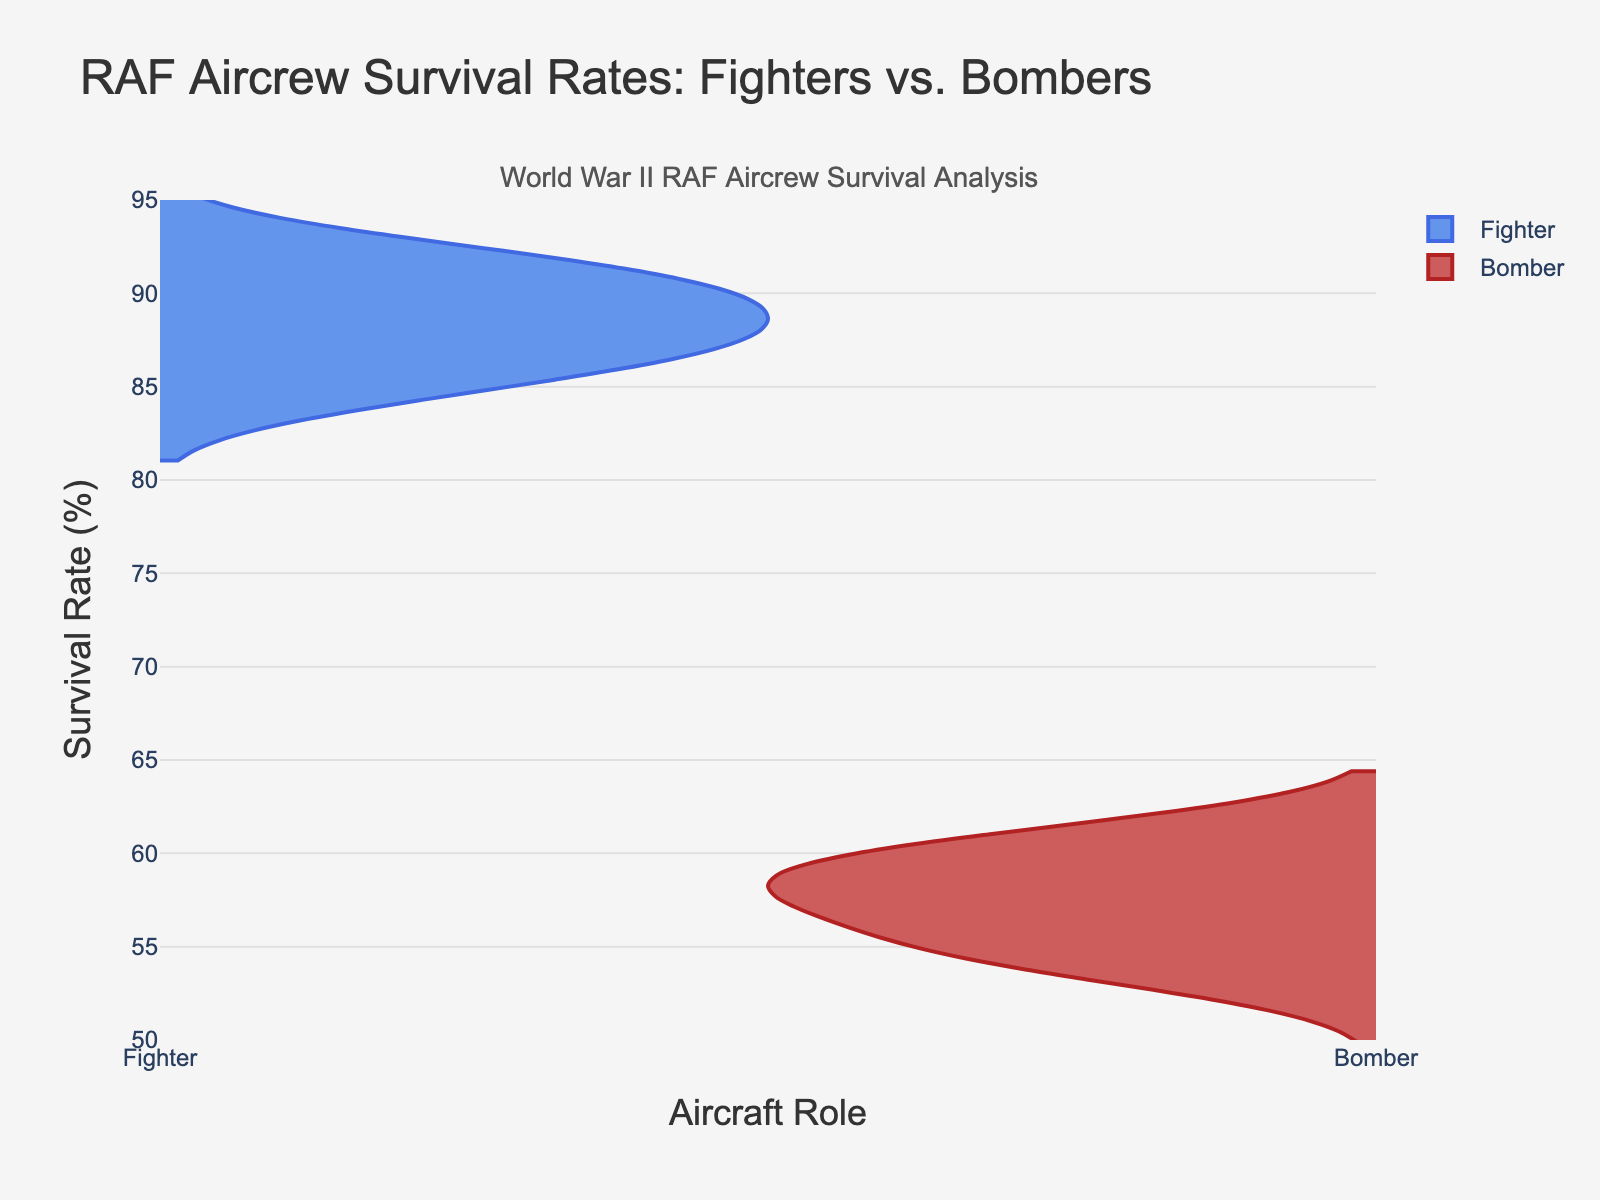What's the title of the figure? The title is usually at the top and provides a description of the figure. In this case, it clearly states what the figure is about.
Answer: "RAF Aircrew Survival Rates: Fighters vs. Bombers" Which color represents the Fighter role in the figure? The color coding for each group should be checked in the legend or in the plot. The Fighter role is colored blue based on the description.
Answer: Blue Approximately what is the range of survival rates for the Bomber role? The range is determined by the highest and lowest values in the Bomber group. Observing the plot, the Bomber survival rates range from around 53% to around 61%.
Answer: 53% to 61% What is the median survival rate for Fighters? The median is the middle value when the data points are arranged in order. For the Fighters: [84.4, 85.9, 86.7, 87.5, 88.0, 89.1, 89.9, 90.2, 91.5, 92.3], the median would be the average of the 5th and 6th numbers. (88.0 + 89.1) / 2 = 88.55.
Answer: 88.55% Compare the general distribution shapes of the Fighter and Bomber roles. Which one appears more spread out? The spread of the data can be observed by looking at the width and length of the violins. The Bomber role appears more spread out as the data points cover a larger range and the shape shows more variability.
Answer: Bomber Looking at the figure, which role has a higher overall survival rate, Fighter or Bomber? By comparing the position of the violins along the y-axis, we see that the survival rates for Fighter are generally higher.
Answer: Fighter What's the survival rate of the lowest data point for Fighters? Look at the bottom of the violin for Fighters to find the lowest data point. The lowest rate is around 84.4%.
Answer: 84.4% If you had to estimate, which role has a smaller interquartile range (IQR), Fighters or Bombers? The IQR is the range between the 25th and 75th percentiles. A visual inspection shows that the Fighters, with a slightly more compact shape, likely have a smaller IQR.
Answer: Fighters What does the annotation "World War II RAF Aircrew Survival Analysis" signify? It provides additional context to the figure, situating the data within the historical period and the specific focus on RAF aircrew survival.
Answer: Provides context on historical analysis 